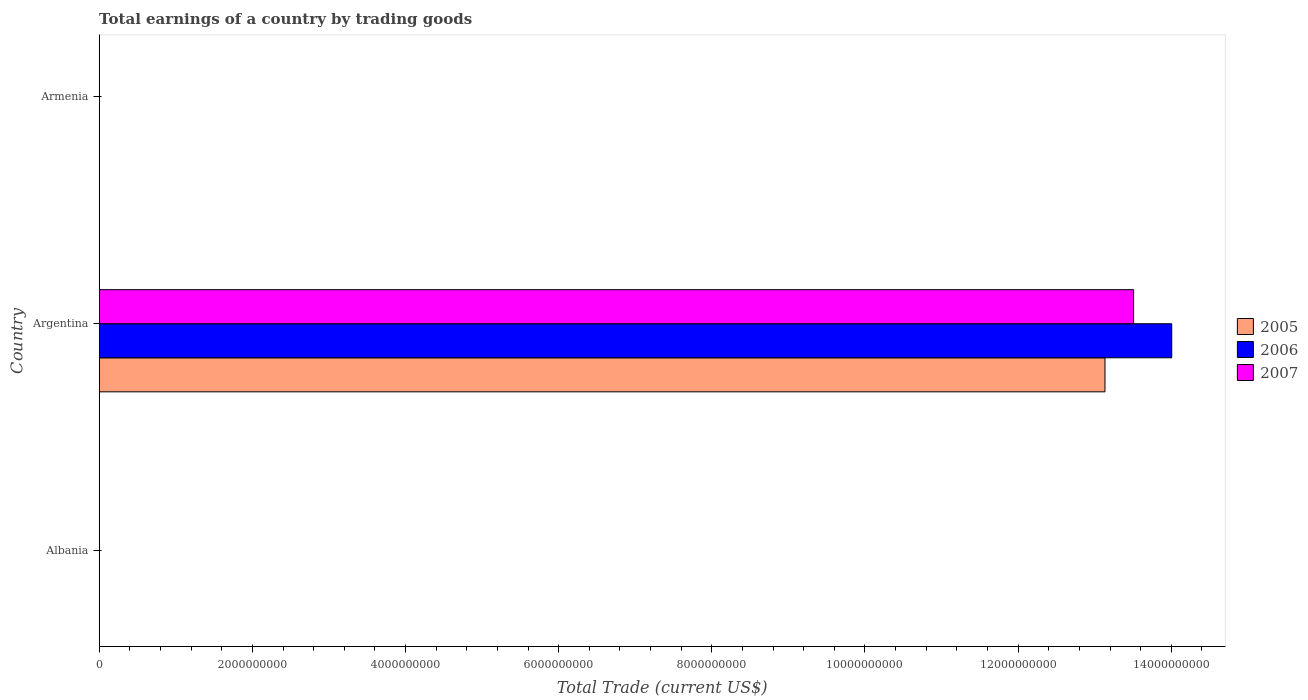How many bars are there on the 1st tick from the bottom?
Offer a terse response. 0. What is the label of the 2nd group of bars from the top?
Make the answer very short. Argentina. What is the total earnings in 2007 in Argentina?
Ensure brevity in your answer.  1.35e+1. Across all countries, what is the maximum total earnings in 2005?
Offer a very short reply. 1.31e+1. In which country was the total earnings in 2005 maximum?
Offer a terse response. Argentina. What is the total total earnings in 2005 in the graph?
Your response must be concise. 1.31e+1. What is the difference between the total earnings in 2007 in Argentina and the total earnings in 2005 in Albania?
Your answer should be very brief. 1.35e+1. What is the average total earnings in 2006 per country?
Offer a terse response. 4.67e+09. What is the difference between the total earnings in 2006 and total earnings in 2007 in Argentina?
Your answer should be compact. 4.98e+08. What is the difference between the highest and the lowest total earnings in 2006?
Keep it short and to the point. 1.40e+1. In how many countries, is the total earnings in 2007 greater than the average total earnings in 2007 taken over all countries?
Offer a terse response. 1. Is it the case that in every country, the sum of the total earnings in 2005 and total earnings in 2006 is greater than the total earnings in 2007?
Your answer should be compact. No. Are all the bars in the graph horizontal?
Your answer should be compact. Yes. Does the graph contain any zero values?
Provide a succinct answer. Yes. Does the graph contain grids?
Your response must be concise. No. Where does the legend appear in the graph?
Make the answer very short. Center right. How many legend labels are there?
Ensure brevity in your answer.  3. What is the title of the graph?
Your answer should be very brief. Total earnings of a country by trading goods. What is the label or title of the X-axis?
Your answer should be compact. Total Trade (current US$). What is the label or title of the Y-axis?
Your answer should be very brief. Country. What is the Total Trade (current US$) in 2006 in Albania?
Ensure brevity in your answer.  0. What is the Total Trade (current US$) of 2007 in Albania?
Provide a succinct answer. 0. What is the Total Trade (current US$) of 2005 in Argentina?
Make the answer very short. 1.31e+1. What is the Total Trade (current US$) in 2006 in Argentina?
Offer a terse response. 1.40e+1. What is the Total Trade (current US$) in 2007 in Argentina?
Provide a short and direct response. 1.35e+1. Across all countries, what is the maximum Total Trade (current US$) of 2005?
Offer a very short reply. 1.31e+1. Across all countries, what is the maximum Total Trade (current US$) of 2006?
Offer a very short reply. 1.40e+1. Across all countries, what is the maximum Total Trade (current US$) of 2007?
Provide a succinct answer. 1.35e+1. Across all countries, what is the minimum Total Trade (current US$) in 2006?
Ensure brevity in your answer.  0. What is the total Total Trade (current US$) in 2005 in the graph?
Your answer should be compact. 1.31e+1. What is the total Total Trade (current US$) of 2006 in the graph?
Give a very brief answer. 1.40e+1. What is the total Total Trade (current US$) of 2007 in the graph?
Provide a short and direct response. 1.35e+1. What is the average Total Trade (current US$) of 2005 per country?
Provide a succinct answer. 4.38e+09. What is the average Total Trade (current US$) of 2006 per country?
Your answer should be compact. 4.67e+09. What is the average Total Trade (current US$) of 2007 per country?
Give a very brief answer. 4.50e+09. What is the difference between the Total Trade (current US$) in 2005 and Total Trade (current US$) in 2006 in Argentina?
Your answer should be very brief. -8.72e+08. What is the difference between the Total Trade (current US$) in 2005 and Total Trade (current US$) in 2007 in Argentina?
Ensure brevity in your answer.  -3.74e+08. What is the difference between the Total Trade (current US$) of 2006 and Total Trade (current US$) of 2007 in Argentina?
Your answer should be very brief. 4.98e+08. What is the difference between the highest and the lowest Total Trade (current US$) of 2005?
Ensure brevity in your answer.  1.31e+1. What is the difference between the highest and the lowest Total Trade (current US$) of 2006?
Your answer should be very brief. 1.40e+1. What is the difference between the highest and the lowest Total Trade (current US$) of 2007?
Ensure brevity in your answer.  1.35e+1. 